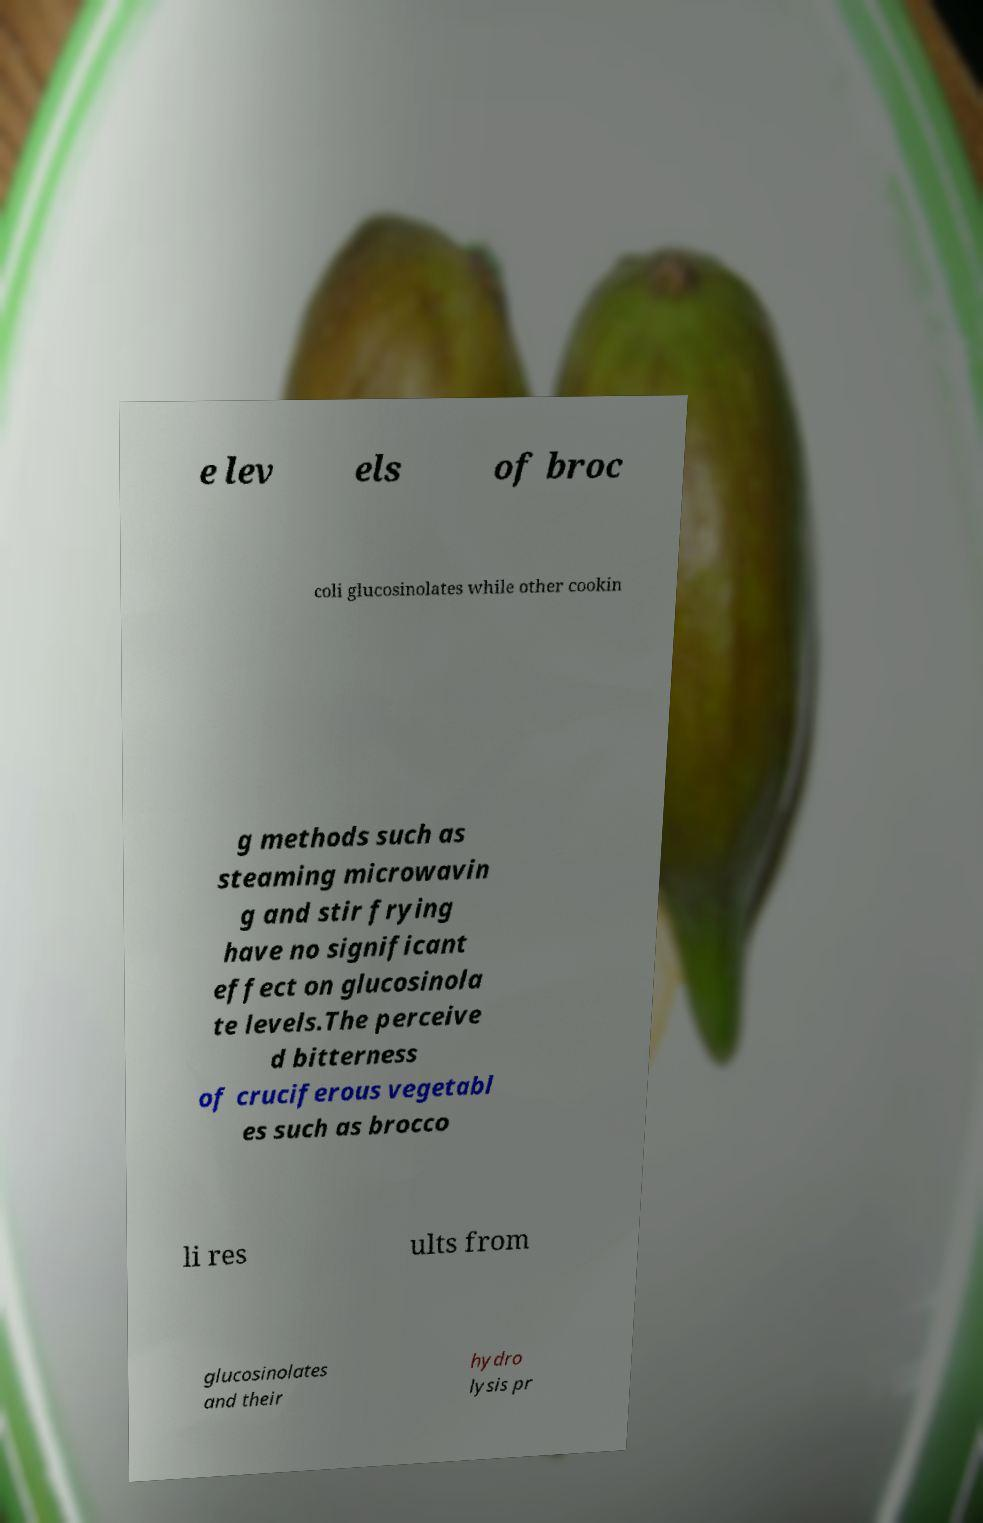I need the written content from this picture converted into text. Can you do that? e lev els of broc coli glucosinolates while other cookin g methods such as steaming microwavin g and stir frying have no significant effect on glucosinola te levels.The perceive d bitterness of cruciferous vegetabl es such as brocco li res ults from glucosinolates and their hydro lysis pr 